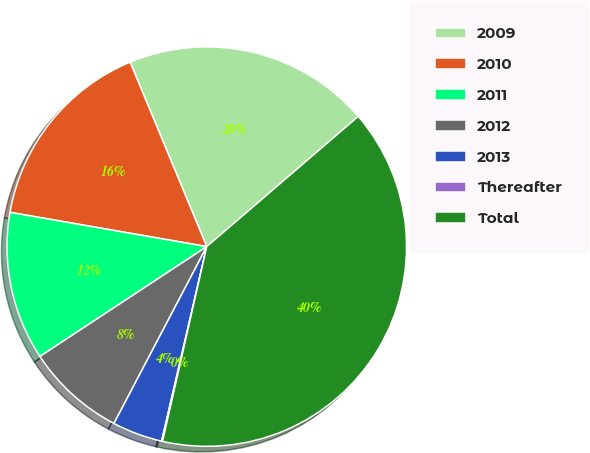Convert chart to OTSL. <chart><loc_0><loc_0><loc_500><loc_500><pie_chart><fcel>2009<fcel>2010<fcel>2011<fcel>2012<fcel>2013<fcel>Thereafter<fcel>Total<nl><fcel>19.97%<fcel>15.99%<fcel>12.01%<fcel>8.04%<fcel>4.06%<fcel>0.08%<fcel>39.85%<nl></chart> 